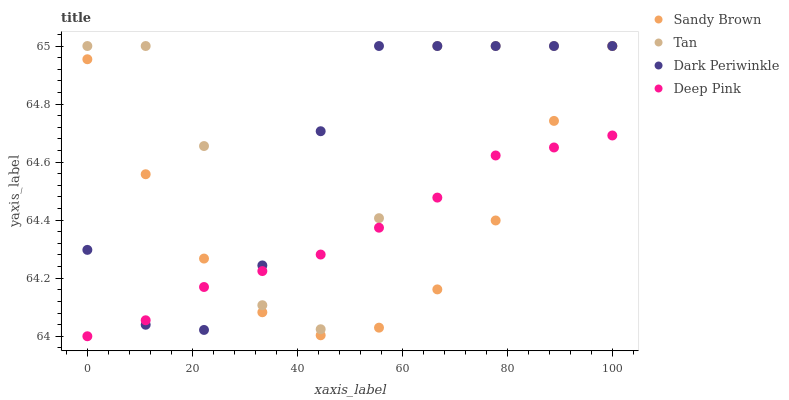Does Deep Pink have the minimum area under the curve?
Answer yes or no. Yes. Does Tan have the maximum area under the curve?
Answer yes or no. Yes. Does Sandy Brown have the minimum area under the curve?
Answer yes or no. No. Does Sandy Brown have the maximum area under the curve?
Answer yes or no. No. Is Deep Pink the smoothest?
Answer yes or no. Yes. Is Tan the roughest?
Answer yes or no. Yes. Is Sandy Brown the smoothest?
Answer yes or no. No. Is Sandy Brown the roughest?
Answer yes or no. No. Does Deep Pink have the lowest value?
Answer yes or no. Yes. Does Sandy Brown have the lowest value?
Answer yes or no. No. Does Dark Periwinkle have the highest value?
Answer yes or no. Yes. Does Deep Pink have the highest value?
Answer yes or no. No. Does Deep Pink intersect Sandy Brown?
Answer yes or no. Yes. Is Deep Pink less than Sandy Brown?
Answer yes or no. No. Is Deep Pink greater than Sandy Brown?
Answer yes or no. No. 